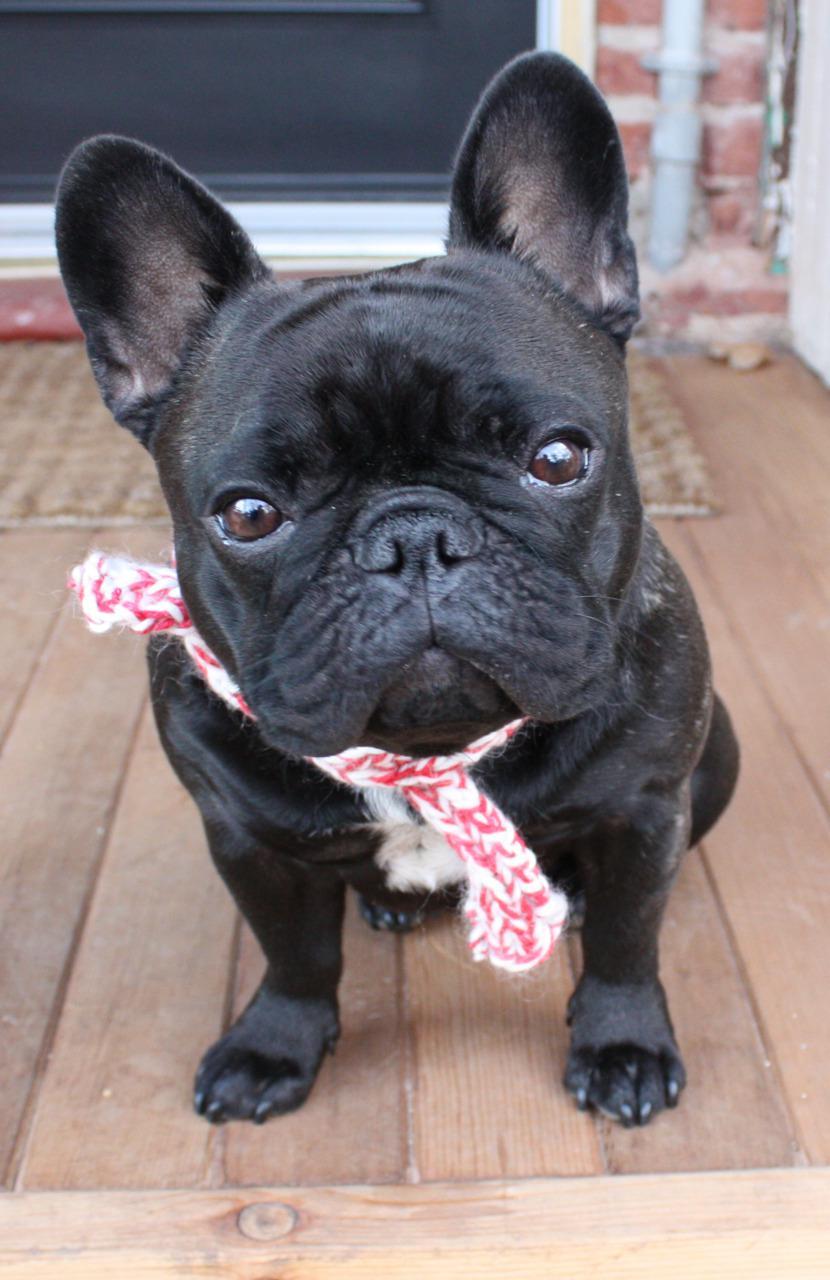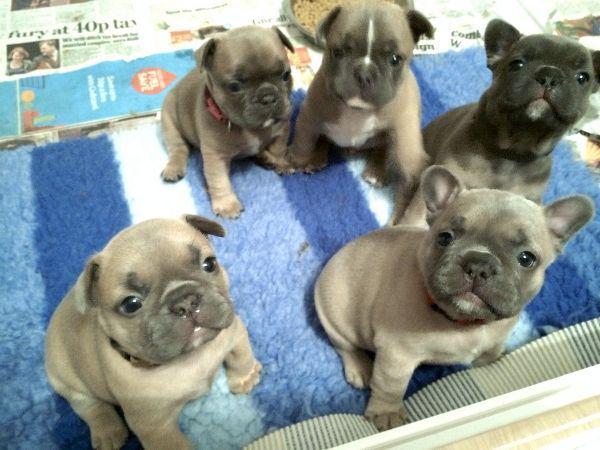The first image is the image on the left, the second image is the image on the right. Given the left and right images, does the statement "There are no more than five dogs in the right image." hold true? Answer yes or no. Yes. 